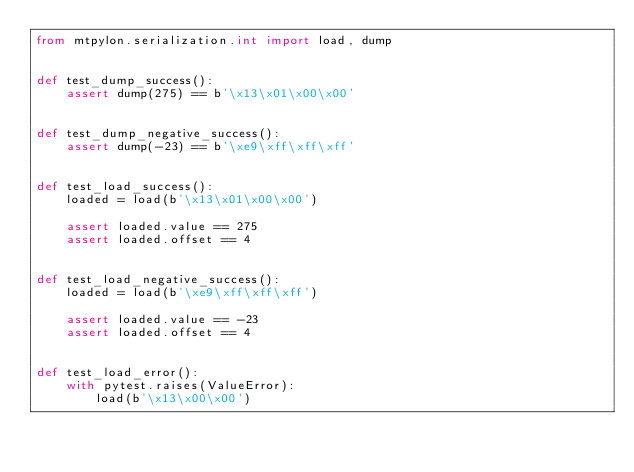<code> <loc_0><loc_0><loc_500><loc_500><_Python_>from mtpylon.serialization.int import load, dump


def test_dump_success():
    assert dump(275) == b'\x13\x01\x00\x00'


def test_dump_negative_success():
    assert dump(-23) == b'\xe9\xff\xff\xff'


def test_load_success():
    loaded = load(b'\x13\x01\x00\x00')

    assert loaded.value == 275
    assert loaded.offset == 4


def test_load_negative_success():
    loaded = load(b'\xe9\xff\xff\xff')

    assert loaded.value == -23
    assert loaded.offset == 4


def test_load_error():
    with pytest.raises(ValueError):
        load(b'\x13\x00\x00')
</code> 